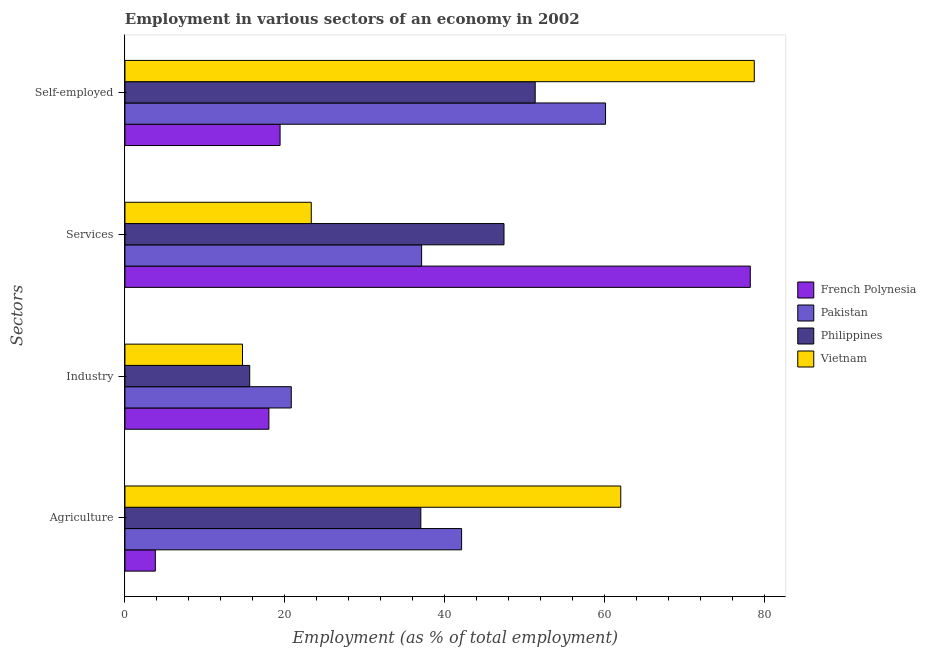How many different coloured bars are there?
Make the answer very short. 4. Are the number of bars per tick equal to the number of legend labels?
Your response must be concise. Yes. Are the number of bars on each tick of the Y-axis equal?
Keep it short and to the point. Yes. How many bars are there on the 3rd tick from the top?
Offer a terse response. 4. How many bars are there on the 4th tick from the bottom?
Make the answer very short. 4. What is the label of the 1st group of bars from the top?
Your answer should be very brief. Self-employed. What is the percentage of workers in industry in French Polynesia?
Your answer should be compact. 18. Across all countries, what is the maximum percentage of workers in industry?
Offer a terse response. 20.8. Across all countries, what is the minimum percentage of self employed workers?
Your answer should be compact. 19.4. In which country was the percentage of workers in services maximum?
Offer a terse response. French Polynesia. In which country was the percentage of self employed workers minimum?
Your answer should be compact. French Polynesia. What is the total percentage of workers in services in the graph?
Make the answer very short. 186. What is the difference between the percentage of workers in industry in Pakistan and that in Philippines?
Keep it short and to the point. 5.2. What is the difference between the percentage of self employed workers in Pakistan and the percentage of workers in industry in French Polynesia?
Offer a very short reply. 42.1. What is the average percentage of self employed workers per country?
Provide a succinct answer. 52.37. What is the difference between the percentage of workers in industry and percentage of workers in agriculture in Philippines?
Your answer should be very brief. -21.4. What is the ratio of the percentage of workers in industry in Pakistan to that in Philippines?
Your response must be concise. 1.33. Is the percentage of workers in industry in French Polynesia less than that in Philippines?
Your answer should be very brief. No. What is the difference between the highest and the second highest percentage of workers in services?
Ensure brevity in your answer.  30.8. What is the difference between the highest and the lowest percentage of self employed workers?
Ensure brevity in your answer.  59.3. Is it the case that in every country, the sum of the percentage of self employed workers and percentage of workers in services is greater than the sum of percentage of workers in industry and percentage of workers in agriculture?
Provide a succinct answer. Yes. What does the 2nd bar from the top in Services represents?
Your answer should be very brief. Philippines. Is it the case that in every country, the sum of the percentage of workers in agriculture and percentage of workers in industry is greater than the percentage of workers in services?
Your answer should be compact. No. Are all the bars in the graph horizontal?
Your answer should be very brief. Yes. Does the graph contain grids?
Your answer should be very brief. No. How many legend labels are there?
Make the answer very short. 4. What is the title of the graph?
Provide a short and direct response. Employment in various sectors of an economy in 2002. Does "Ecuador" appear as one of the legend labels in the graph?
Provide a short and direct response. No. What is the label or title of the X-axis?
Your response must be concise. Employment (as % of total employment). What is the label or title of the Y-axis?
Ensure brevity in your answer.  Sectors. What is the Employment (as % of total employment) in French Polynesia in Agriculture?
Provide a short and direct response. 3.8. What is the Employment (as % of total employment) of Pakistan in Agriculture?
Make the answer very short. 42.1. What is the Employment (as % of total employment) in Philippines in Agriculture?
Give a very brief answer. 37. What is the Employment (as % of total employment) in French Polynesia in Industry?
Make the answer very short. 18. What is the Employment (as % of total employment) of Pakistan in Industry?
Your answer should be compact. 20.8. What is the Employment (as % of total employment) of Philippines in Industry?
Your answer should be compact. 15.6. What is the Employment (as % of total employment) in Vietnam in Industry?
Your answer should be very brief. 14.7. What is the Employment (as % of total employment) in French Polynesia in Services?
Your answer should be compact. 78.2. What is the Employment (as % of total employment) in Pakistan in Services?
Your answer should be very brief. 37.1. What is the Employment (as % of total employment) in Philippines in Services?
Offer a terse response. 47.4. What is the Employment (as % of total employment) of Vietnam in Services?
Give a very brief answer. 23.3. What is the Employment (as % of total employment) in French Polynesia in Self-employed?
Your answer should be very brief. 19.4. What is the Employment (as % of total employment) of Pakistan in Self-employed?
Ensure brevity in your answer.  60.1. What is the Employment (as % of total employment) of Philippines in Self-employed?
Keep it short and to the point. 51.3. What is the Employment (as % of total employment) in Vietnam in Self-employed?
Offer a very short reply. 78.7. Across all Sectors, what is the maximum Employment (as % of total employment) in French Polynesia?
Your response must be concise. 78.2. Across all Sectors, what is the maximum Employment (as % of total employment) in Pakistan?
Provide a succinct answer. 60.1. Across all Sectors, what is the maximum Employment (as % of total employment) in Philippines?
Provide a succinct answer. 51.3. Across all Sectors, what is the maximum Employment (as % of total employment) of Vietnam?
Ensure brevity in your answer.  78.7. Across all Sectors, what is the minimum Employment (as % of total employment) in French Polynesia?
Your response must be concise. 3.8. Across all Sectors, what is the minimum Employment (as % of total employment) in Pakistan?
Your answer should be compact. 20.8. Across all Sectors, what is the minimum Employment (as % of total employment) in Philippines?
Ensure brevity in your answer.  15.6. Across all Sectors, what is the minimum Employment (as % of total employment) in Vietnam?
Provide a short and direct response. 14.7. What is the total Employment (as % of total employment) in French Polynesia in the graph?
Provide a short and direct response. 119.4. What is the total Employment (as % of total employment) of Pakistan in the graph?
Keep it short and to the point. 160.1. What is the total Employment (as % of total employment) in Philippines in the graph?
Ensure brevity in your answer.  151.3. What is the total Employment (as % of total employment) in Vietnam in the graph?
Your response must be concise. 178.7. What is the difference between the Employment (as % of total employment) of French Polynesia in Agriculture and that in Industry?
Your answer should be very brief. -14.2. What is the difference between the Employment (as % of total employment) in Pakistan in Agriculture and that in Industry?
Ensure brevity in your answer.  21.3. What is the difference between the Employment (as % of total employment) of Philippines in Agriculture and that in Industry?
Offer a terse response. 21.4. What is the difference between the Employment (as % of total employment) of Vietnam in Agriculture and that in Industry?
Offer a very short reply. 47.3. What is the difference between the Employment (as % of total employment) in French Polynesia in Agriculture and that in Services?
Offer a terse response. -74.4. What is the difference between the Employment (as % of total employment) of Philippines in Agriculture and that in Services?
Keep it short and to the point. -10.4. What is the difference between the Employment (as % of total employment) in Vietnam in Agriculture and that in Services?
Offer a very short reply. 38.7. What is the difference between the Employment (as % of total employment) of French Polynesia in Agriculture and that in Self-employed?
Give a very brief answer. -15.6. What is the difference between the Employment (as % of total employment) in Pakistan in Agriculture and that in Self-employed?
Offer a terse response. -18. What is the difference between the Employment (as % of total employment) of Philippines in Agriculture and that in Self-employed?
Your answer should be very brief. -14.3. What is the difference between the Employment (as % of total employment) of Vietnam in Agriculture and that in Self-employed?
Make the answer very short. -16.7. What is the difference between the Employment (as % of total employment) of French Polynesia in Industry and that in Services?
Keep it short and to the point. -60.2. What is the difference between the Employment (as % of total employment) of Pakistan in Industry and that in Services?
Provide a succinct answer. -16.3. What is the difference between the Employment (as % of total employment) of Philippines in Industry and that in Services?
Make the answer very short. -31.8. What is the difference between the Employment (as % of total employment) of Vietnam in Industry and that in Services?
Ensure brevity in your answer.  -8.6. What is the difference between the Employment (as % of total employment) of French Polynesia in Industry and that in Self-employed?
Keep it short and to the point. -1.4. What is the difference between the Employment (as % of total employment) in Pakistan in Industry and that in Self-employed?
Make the answer very short. -39.3. What is the difference between the Employment (as % of total employment) in Philippines in Industry and that in Self-employed?
Make the answer very short. -35.7. What is the difference between the Employment (as % of total employment) in Vietnam in Industry and that in Self-employed?
Keep it short and to the point. -64. What is the difference between the Employment (as % of total employment) in French Polynesia in Services and that in Self-employed?
Give a very brief answer. 58.8. What is the difference between the Employment (as % of total employment) in Philippines in Services and that in Self-employed?
Provide a short and direct response. -3.9. What is the difference between the Employment (as % of total employment) of Vietnam in Services and that in Self-employed?
Offer a very short reply. -55.4. What is the difference between the Employment (as % of total employment) of French Polynesia in Agriculture and the Employment (as % of total employment) of Philippines in Industry?
Your answer should be compact. -11.8. What is the difference between the Employment (as % of total employment) in French Polynesia in Agriculture and the Employment (as % of total employment) in Vietnam in Industry?
Offer a terse response. -10.9. What is the difference between the Employment (as % of total employment) in Pakistan in Agriculture and the Employment (as % of total employment) in Vietnam in Industry?
Give a very brief answer. 27.4. What is the difference between the Employment (as % of total employment) of Philippines in Agriculture and the Employment (as % of total employment) of Vietnam in Industry?
Your response must be concise. 22.3. What is the difference between the Employment (as % of total employment) in French Polynesia in Agriculture and the Employment (as % of total employment) in Pakistan in Services?
Your answer should be very brief. -33.3. What is the difference between the Employment (as % of total employment) of French Polynesia in Agriculture and the Employment (as % of total employment) of Philippines in Services?
Your answer should be very brief. -43.6. What is the difference between the Employment (as % of total employment) of French Polynesia in Agriculture and the Employment (as % of total employment) of Vietnam in Services?
Offer a terse response. -19.5. What is the difference between the Employment (as % of total employment) in Pakistan in Agriculture and the Employment (as % of total employment) in Philippines in Services?
Give a very brief answer. -5.3. What is the difference between the Employment (as % of total employment) in Philippines in Agriculture and the Employment (as % of total employment) in Vietnam in Services?
Offer a terse response. 13.7. What is the difference between the Employment (as % of total employment) of French Polynesia in Agriculture and the Employment (as % of total employment) of Pakistan in Self-employed?
Provide a succinct answer. -56.3. What is the difference between the Employment (as % of total employment) of French Polynesia in Agriculture and the Employment (as % of total employment) of Philippines in Self-employed?
Offer a very short reply. -47.5. What is the difference between the Employment (as % of total employment) in French Polynesia in Agriculture and the Employment (as % of total employment) in Vietnam in Self-employed?
Offer a terse response. -74.9. What is the difference between the Employment (as % of total employment) of Pakistan in Agriculture and the Employment (as % of total employment) of Vietnam in Self-employed?
Offer a very short reply. -36.6. What is the difference between the Employment (as % of total employment) of Philippines in Agriculture and the Employment (as % of total employment) of Vietnam in Self-employed?
Give a very brief answer. -41.7. What is the difference between the Employment (as % of total employment) of French Polynesia in Industry and the Employment (as % of total employment) of Pakistan in Services?
Offer a terse response. -19.1. What is the difference between the Employment (as % of total employment) of French Polynesia in Industry and the Employment (as % of total employment) of Philippines in Services?
Provide a succinct answer. -29.4. What is the difference between the Employment (as % of total employment) in Pakistan in Industry and the Employment (as % of total employment) in Philippines in Services?
Make the answer very short. -26.6. What is the difference between the Employment (as % of total employment) in French Polynesia in Industry and the Employment (as % of total employment) in Pakistan in Self-employed?
Your answer should be very brief. -42.1. What is the difference between the Employment (as % of total employment) in French Polynesia in Industry and the Employment (as % of total employment) in Philippines in Self-employed?
Make the answer very short. -33.3. What is the difference between the Employment (as % of total employment) of French Polynesia in Industry and the Employment (as % of total employment) of Vietnam in Self-employed?
Offer a terse response. -60.7. What is the difference between the Employment (as % of total employment) of Pakistan in Industry and the Employment (as % of total employment) of Philippines in Self-employed?
Make the answer very short. -30.5. What is the difference between the Employment (as % of total employment) of Pakistan in Industry and the Employment (as % of total employment) of Vietnam in Self-employed?
Provide a succinct answer. -57.9. What is the difference between the Employment (as % of total employment) of Philippines in Industry and the Employment (as % of total employment) of Vietnam in Self-employed?
Your response must be concise. -63.1. What is the difference between the Employment (as % of total employment) of French Polynesia in Services and the Employment (as % of total employment) of Philippines in Self-employed?
Provide a short and direct response. 26.9. What is the difference between the Employment (as % of total employment) in French Polynesia in Services and the Employment (as % of total employment) in Vietnam in Self-employed?
Offer a very short reply. -0.5. What is the difference between the Employment (as % of total employment) of Pakistan in Services and the Employment (as % of total employment) of Philippines in Self-employed?
Your response must be concise. -14.2. What is the difference between the Employment (as % of total employment) in Pakistan in Services and the Employment (as % of total employment) in Vietnam in Self-employed?
Your answer should be compact. -41.6. What is the difference between the Employment (as % of total employment) of Philippines in Services and the Employment (as % of total employment) of Vietnam in Self-employed?
Make the answer very short. -31.3. What is the average Employment (as % of total employment) in French Polynesia per Sectors?
Offer a very short reply. 29.85. What is the average Employment (as % of total employment) of Pakistan per Sectors?
Your response must be concise. 40.02. What is the average Employment (as % of total employment) of Philippines per Sectors?
Your answer should be very brief. 37.83. What is the average Employment (as % of total employment) in Vietnam per Sectors?
Offer a very short reply. 44.67. What is the difference between the Employment (as % of total employment) of French Polynesia and Employment (as % of total employment) of Pakistan in Agriculture?
Offer a terse response. -38.3. What is the difference between the Employment (as % of total employment) in French Polynesia and Employment (as % of total employment) in Philippines in Agriculture?
Provide a short and direct response. -33.2. What is the difference between the Employment (as % of total employment) in French Polynesia and Employment (as % of total employment) in Vietnam in Agriculture?
Give a very brief answer. -58.2. What is the difference between the Employment (as % of total employment) in Pakistan and Employment (as % of total employment) in Philippines in Agriculture?
Provide a succinct answer. 5.1. What is the difference between the Employment (as % of total employment) in Pakistan and Employment (as % of total employment) in Vietnam in Agriculture?
Your response must be concise. -19.9. What is the difference between the Employment (as % of total employment) of Pakistan and Employment (as % of total employment) of Philippines in Industry?
Keep it short and to the point. 5.2. What is the difference between the Employment (as % of total employment) of Pakistan and Employment (as % of total employment) of Vietnam in Industry?
Provide a short and direct response. 6.1. What is the difference between the Employment (as % of total employment) in French Polynesia and Employment (as % of total employment) in Pakistan in Services?
Your response must be concise. 41.1. What is the difference between the Employment (as % of total employment) of French Polynesia and Employment (as % of total employment) of Philippines in Services?
Your response must be concise. 30.8. What is the difference between the Employment (as % of total employment) of French Polynesia and Employment (as % of total employment) of Vietnam in Services?
Give a very brief answer. 54.9. What is the difference between the Employment (as % of total employment) in Philippines and Employment (as % of total employment) in Vietnam in Services?
Your response must be concise. 24.1. What is the difference between the Employment (as % of total employment) in French Polynesia and Employment (as % of total employment) in Pakistan in Self-employed?
Provide a short and direct response. -40.7. What is the difference between the Employment (as % of total employment) in French Polynesia and Employment (as % of total employment) in Philippines in Self-employed?
Your answer should be very brief. -31.9. What is the difference between the Employment (as % of total employment) of French Polynesia and Employment (as % of total employment) of Vietnam in Self-employed?
Keep it short and to the point. -59.3. What is the difference between the Employment (as % of total employment) of Pakistan and Employment (as % of total employment) of Philippines in Self-employed?
Keep it short and to the point. 8.8. What is the difference between the Employment (as % of total employment) of Pakistan and Employment (as % of total employment) of Vietnam in Self-employed?
Offer a terse response. -18.6. What is the difference between the Employment (as % of total employment) of Philippines and Employment (as % of total employment) of Vietnam in Self-employed?
Ensure brevity in your answer.  -27.4. What is the ratio of the Employment (as % of total employment) in French Polynesia in Agriculture to that in Industry?
Ensure brevity in your answer.  0.21. What is the ratio of the Employment (as % of total employment) in Pakistan in Agriculture to that in Industry?
Offer a terse response. 2.02. What is the ratio of the Employment (as % of total employment) in Philippines in Agriculture to that in Industry?
Make the answer very short. 2.37. What is the ratio of the Employment (as % of total employment) in Vietnam in Agriculture to that in Industry?
Keep it short and to the point. 4.22. What is the ratio of the Employment (as % of total employment) of French Polynesia in Agriculture to that in Services?
Offer a terse response. 0.05. What is the ratio of the Employment (as % of total employment) in Pakistan in Agriculture to that in Services?
Give a very brief answer. 1.13. What is the ratio of the Employment (as % of total employment) of Philippines in Agriculture to that in Services?
Give a very brief answer. 0.78. What is the ratio of the Employment (as % of total employment) in Vietnam in Agriculture to that in Services?
Keep it short and to the point. 2.66. What is the ratio of the Employment (as % of total employment) in French Polynesia in Agriculture to that in Self-employed?
Your answer should be compact. 0.2. What is the ratio of the Employment (as % of total employment) of Pakistan in Agriculture to that in Self-employed?
Your answer should be compact. 0.7. What is the ratio of the Employment (as % of total employment) in Philippines in Agriculture to that in Self-employed?
Your answer should be compact. 0.72. What is the ratio of the Employment (as % of total employment) in Vietnam in Agriculture to that in Self-employed?
Provide a short and direct response. 0.79. What is the ratio of the Employment (as % of total employment) in French Polynesia in Industry to that in Services?
Your answer should be compact. 0.23. What is the ratio of the Employment (as % of total employment) in Pakistan in Industry to that in Services?
Offer a terse response. 0.56. What is the ratio of the Employment (as % of total employment) in Philippines in Industry to that in Services?
Offer a terse response. 0.33. What is the ratio of the Employment (as % of total employment) of Vietnam in Industry to that in Services?
Offer a very short reply. 0.63. What is the ratio of the Employment (as % of total employment) in French Polynesia in Industry to that in Self-employed?
Offer a very short reply. 0.93. What is the ratio of the Employment (as % of total employment) of Pakistan in Industry to that in Self-employed?
Keep it short and to the point. 0.35. What is the ratio of the Employment (as % of total employment) in Philippines in Industry to that in Self-employed?
Keep it short and to the point. 0.3. What is the ratio of the Employment (as % of total employment) in Vietnam in Industry to that in Self-employed?
Your response must be concise. 0.19. What is the ratio of the Employment (as % of total employment) in French Polynesia in Services to that in Self-employed?
Provide a succinct answer. 4.03. What is the ratio of the Employment (as % of total employment) of Pakistan in Services to that in Self-employed?
Offer a terse response. 0.62. What is the ratio of the Employment (as % of total employment) in Philippines in Services to that in Self-employed?
Ensure brevity in your answer.  0.92. What is the ratio of the Employment (as % of total employment) of Vietnam in Services to that in Self-employed?
Offer a very short reply. 0.3. What is the difference between the highest and the second highest Employment (as % of total employment) in French Polynesia?
Offer a very short reply. 58.8. What is the difference between the highest and the second highest Employment (as % of total employment) in Vietnam?
Provide a short and direct response. 16.7. What is the difference between the highest and the lowest Employment (as % of total employment) in French Polynesia?
Your answer should be very brief. 74.4. What is the difference between the highest and the lowest Employment (as % of total employment) of Pakistan?
Make the answer very short. 39.3. What is the difference between the highest and the lowest Employment (as % of total employment) in Philippines?
Your answer should be compact. 35.7. 